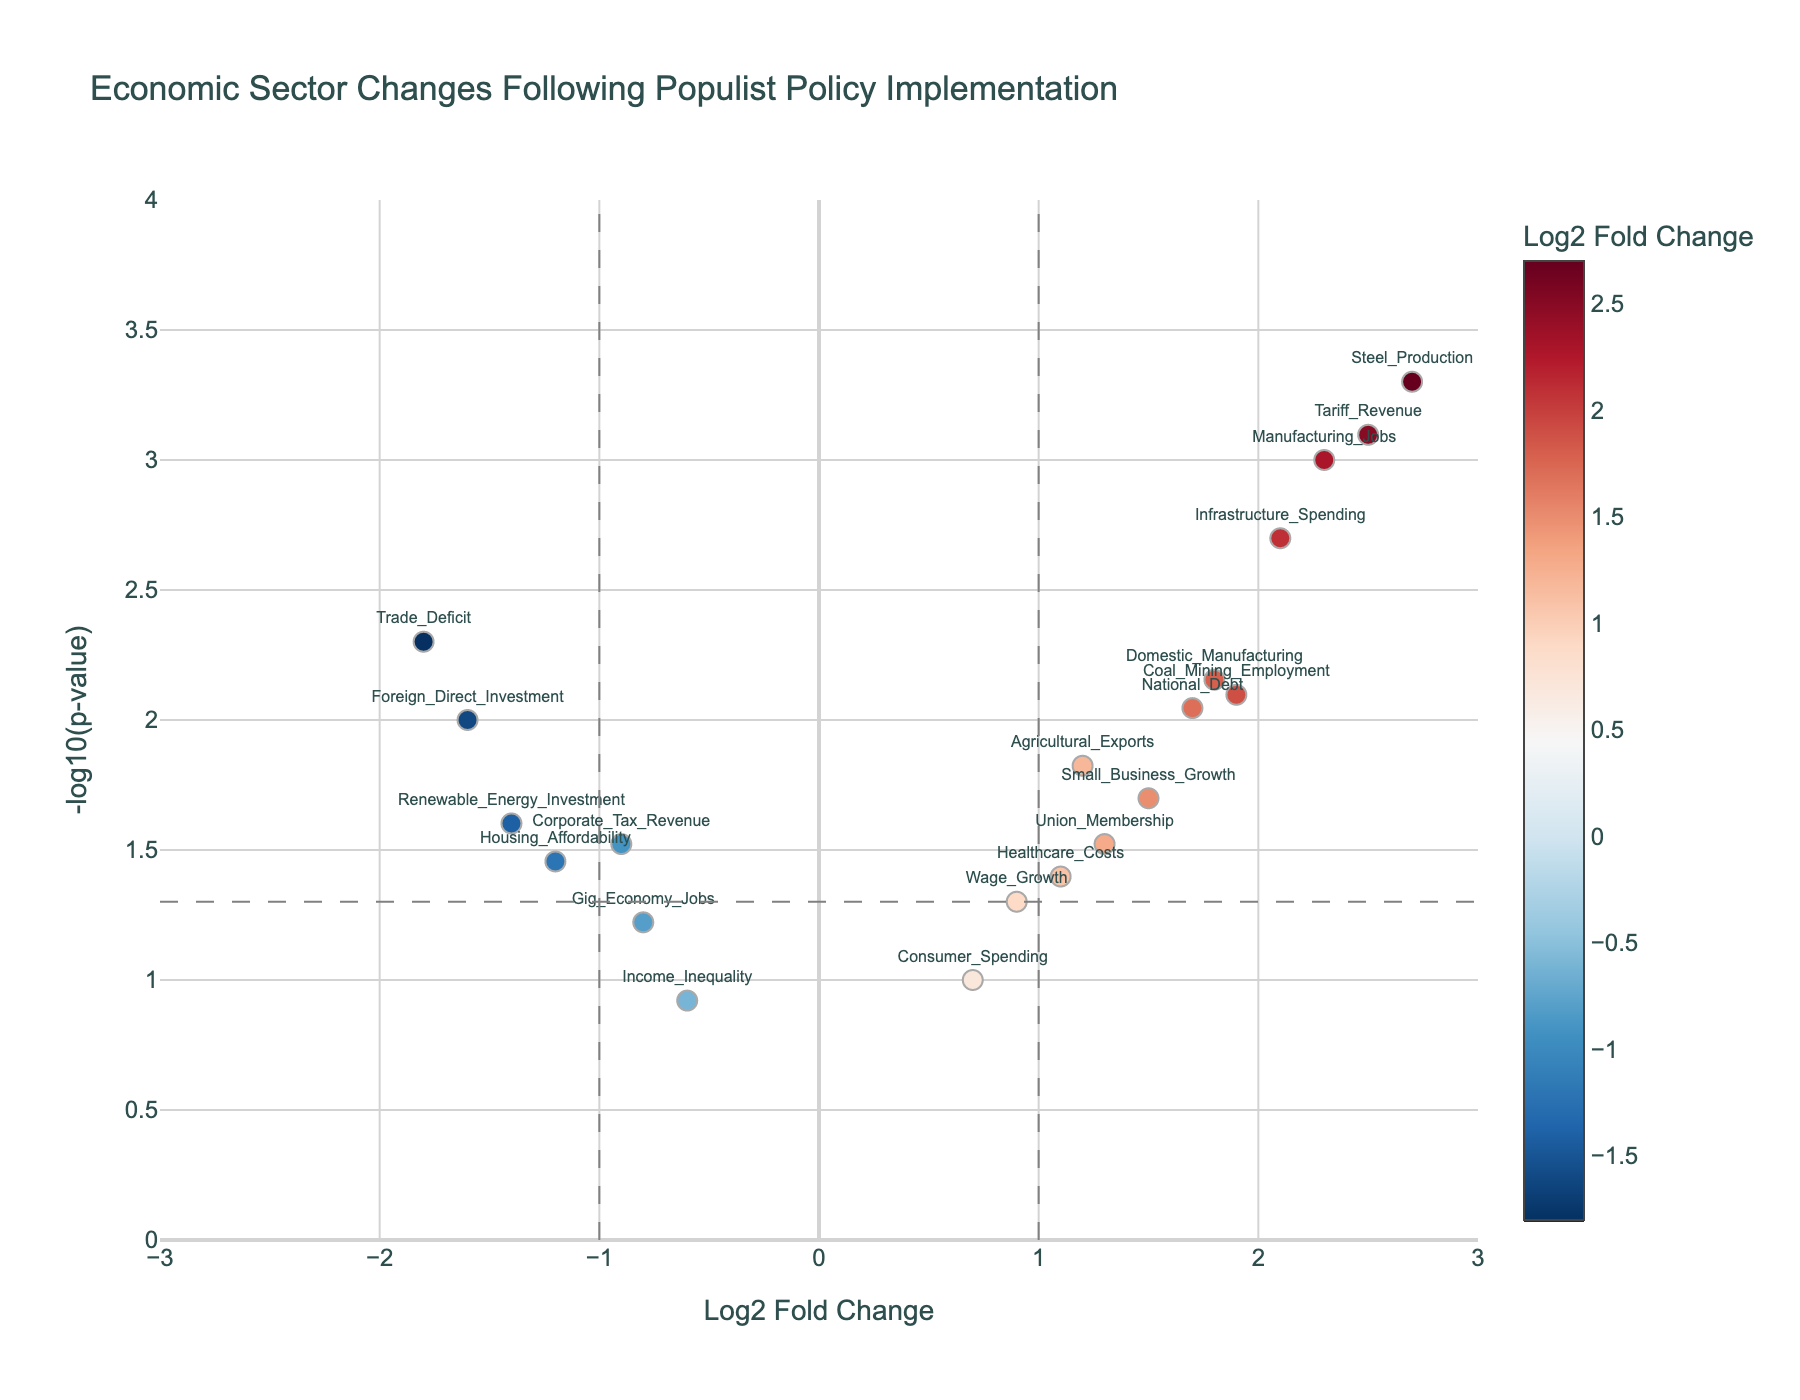What is the title of the figure? The title of the figure is generally placed at the top and summarizes the main content. In this case, it reads "Economic Sector Changes Following Populist Policy Implementation".
Answer: Economic Sector Changes Following Populist Policy Implementation Which economic sector has the highest Log2 Fold Change? Locate the data point on the x-axis with the highest positive value. "Steel_Production" has a Log2 Fold Change of 2.7.
Answer: Steel_Production How many data points have a P-Value less than 0.05? Count all the data points that fall above the threshold line at -log10(0.05). A total of 14 data points are above it.
Answer: 14 Which sector has the smallest p-value? The smallest p-value corresponds to the data point with the highest value on the y-axis. "Steel_Production" has the highest -log10(p-value), suggesting the smallest p-value.
Answer: Steel_Production What is the Log2 Fold Change and p-value for "National_Debt"? Find the "National_Debt" on the figure and check its x and y coordinates or hover info. It has a Log2 Fold Change of 1.7 and a p-value of 0.009.
Answer: Log2FoldChange: 1.7, p-value: 0.009 How many economic sectors show negative Log2 Fold Changes? Count all the data points located on the left side of the y-axis (negative x values), which totals up to 7 sectors.
Answer: 7 Which sectors have both a positive Log2 Fold Change greater than 1 and a p-value less than 0.01? Identify the sectors on the right of x = 1 and above -log10(0.01). These sectors are "Manufacturing_Jobs", "Steel_Production", "Infrastructure_Spending", "Tariff_Revenue", and "Domestic_Manufacturing".
Answer: Manufacturing_Jobs, Steel_Production, Infrastructure_Spending, Tariff_Revenue, Domestic_Manufacturing Which sectors fall in the lower right quadrant (positive Log2 Fold Change but higher p-value)? Locate the sectors with positive x values but y values below the threshold line. "Consumer_Spending" and "Wage_Growth" are examples.
Answer: Consumer_Spending, Wage_Growth What is the range of Log2 Fold Change values in the plot? Note the smallest and largest x-values in the plot; the range goes from around -1.8 to 2.7.
Answer: From -1.8 to 2.7 Which sectors show a significant increase or decrease in their Log2 Fold Change? Sectors significantly changed will be far from zero along the x-axis and above the -log10(0.05) line. Examples include "Steel_Production", "Manufacturing_Jobs", "Tariff_Revenue", and "Trade_Deficit".
Answer: Steel_Production, Manufacturing_Jobs, Tariff_Revenue, Trade_Deficit 